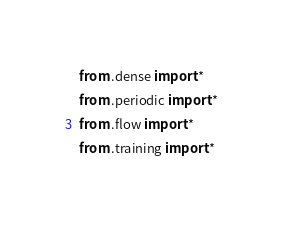<code> <loc_0><loc_0><loc_500><loc_500><_Python_>from .dense import *
from .periodic import *
from .flow import *
from .training import *
</code> 